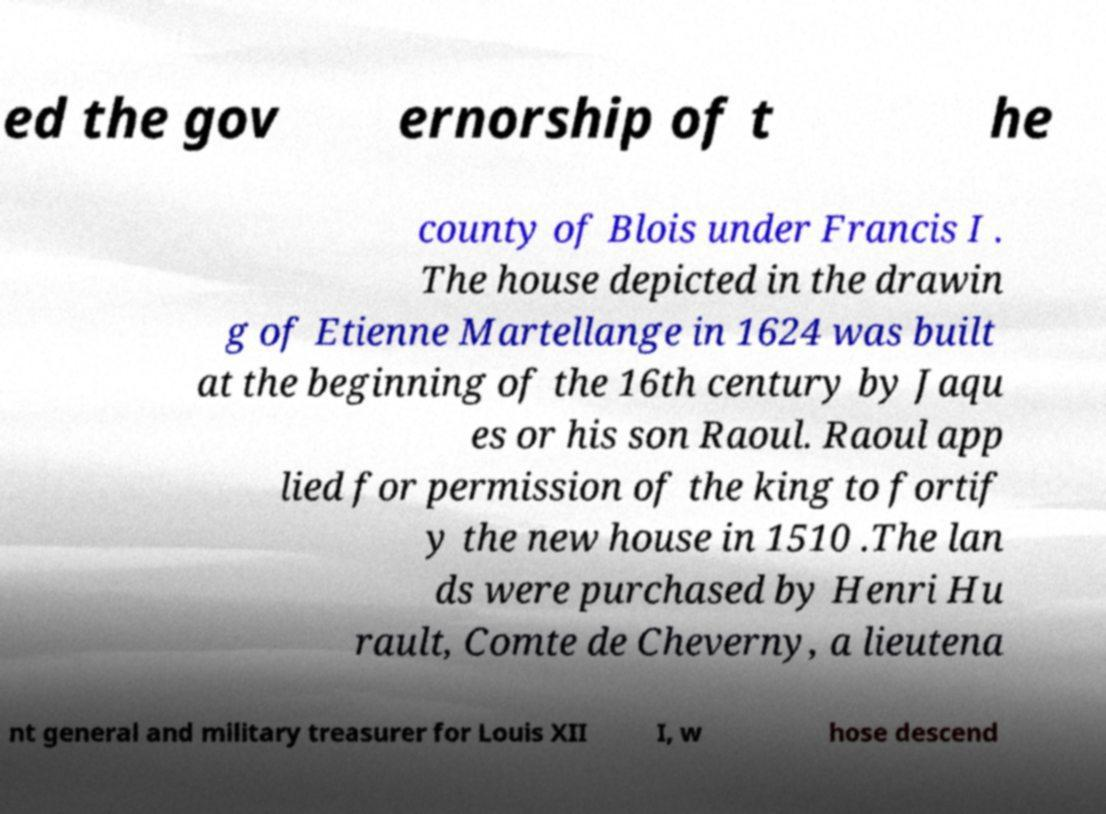Could you assist in decoding the text presented in this image and type it out clearly? ed the gov ernorship of t he county of Blois under Francis I . The house depicted in the drawin g of Etienne Martellange in 1624 was built at the beginning of the 16th century by Jaqu es or his son Raoul. Raoul app lied for permission of the king to fortif y the new house in 1510 .The lan ds were purchased by Henri Hu rault, Comte de Cheverny, a lieutena nt general and military treasurer for Louis XII I, w hose descend 